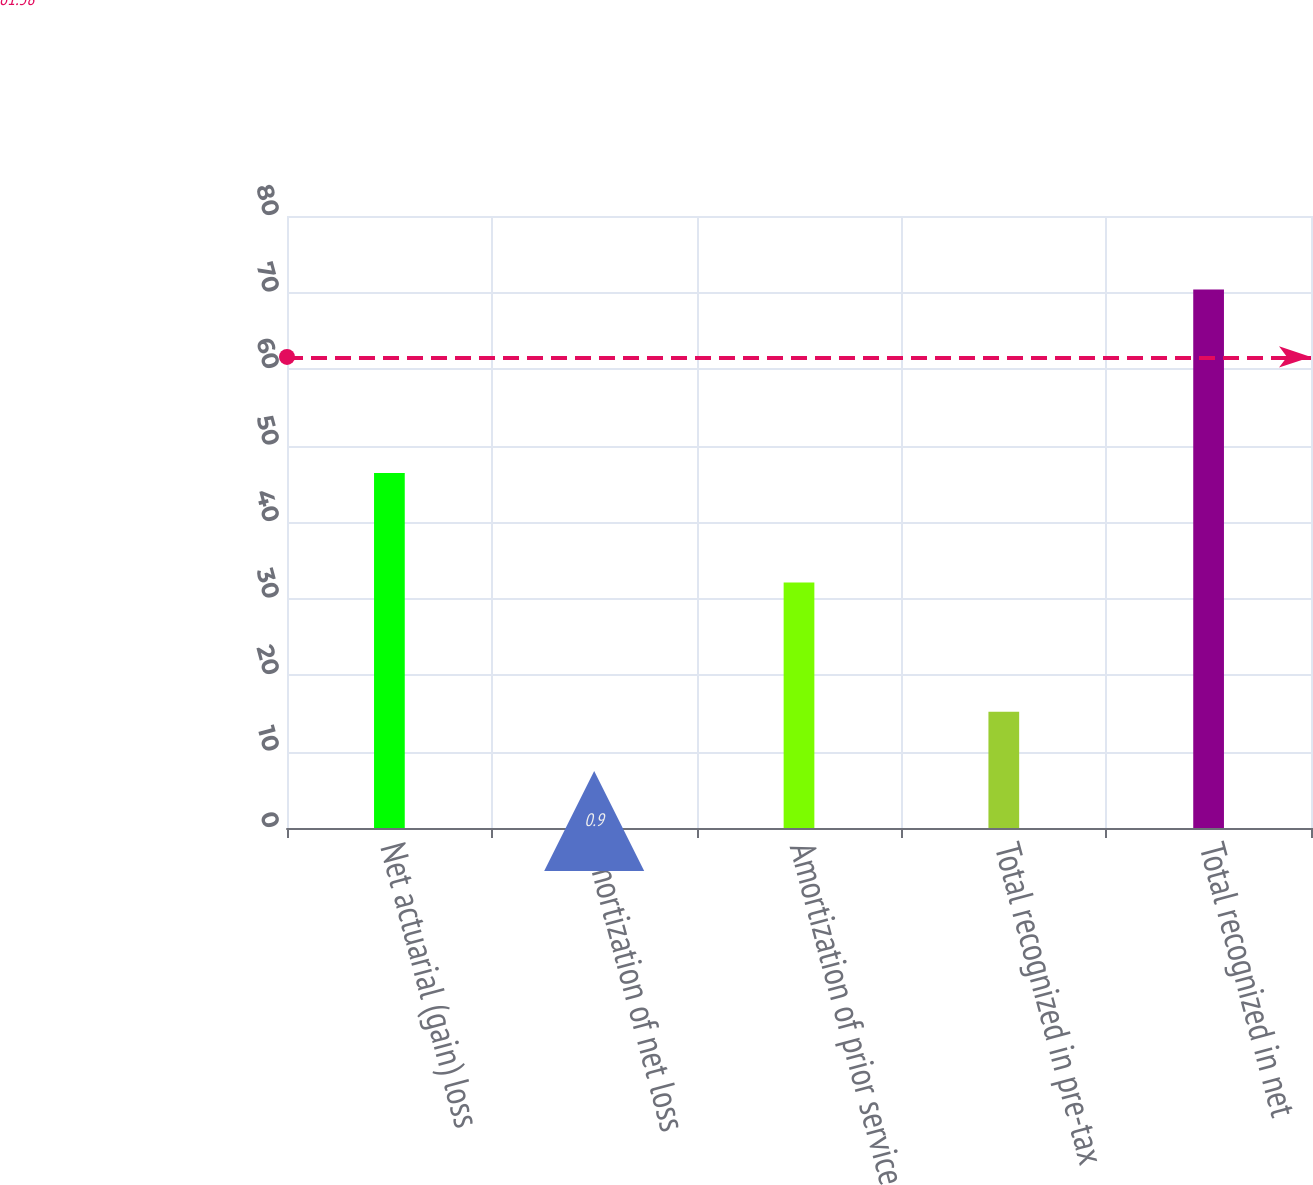Convert chart. <chart><loc_0><loc_0><loc_500><loc_500><bar_chart><fcel>Net actuarial (gain) loss<fcel>Amortization of net loss<fcel>Amortization of prior service<fcel>Total recognized in pre-tax<fcel>Total recognized in net<nl><fcel>46.4<fcel>0.9<fcel>32.1<fcel>15.2<fcel>70.4<nl></chart> 